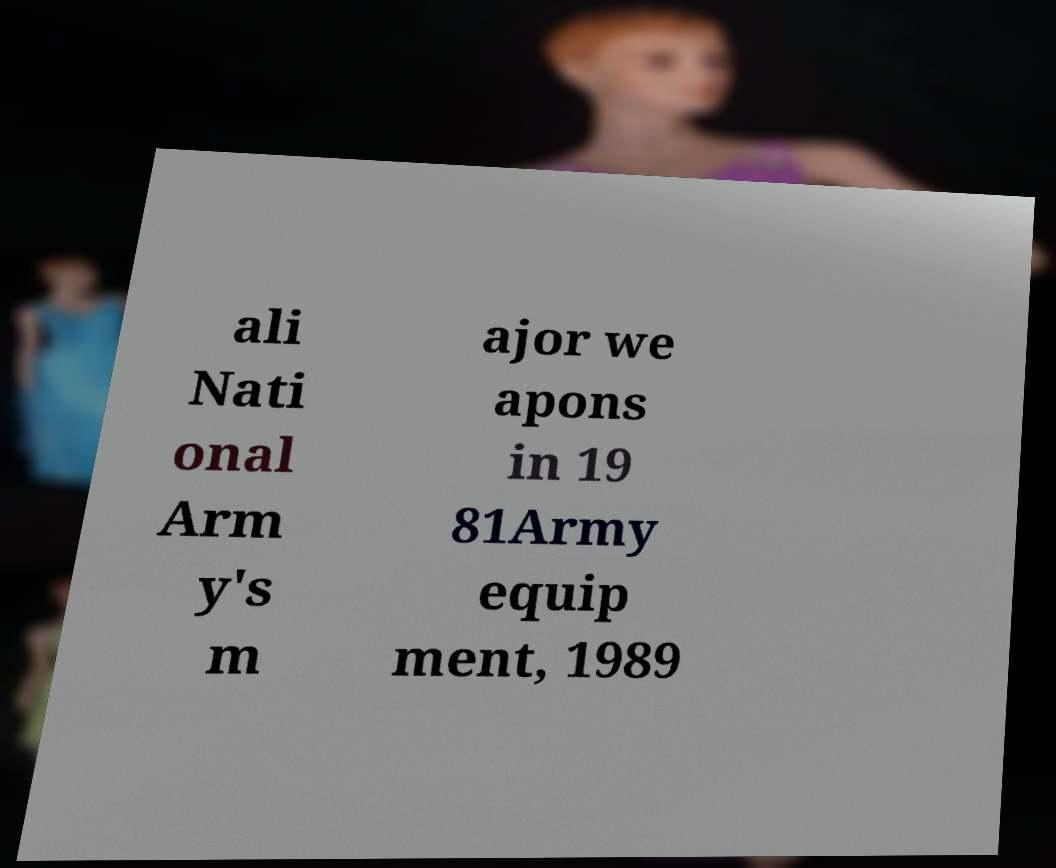Please identify and transcribe the text found in this image. ali Nati onal Arm y's m ajor we apons in 19 81Army equip ment, 1989 